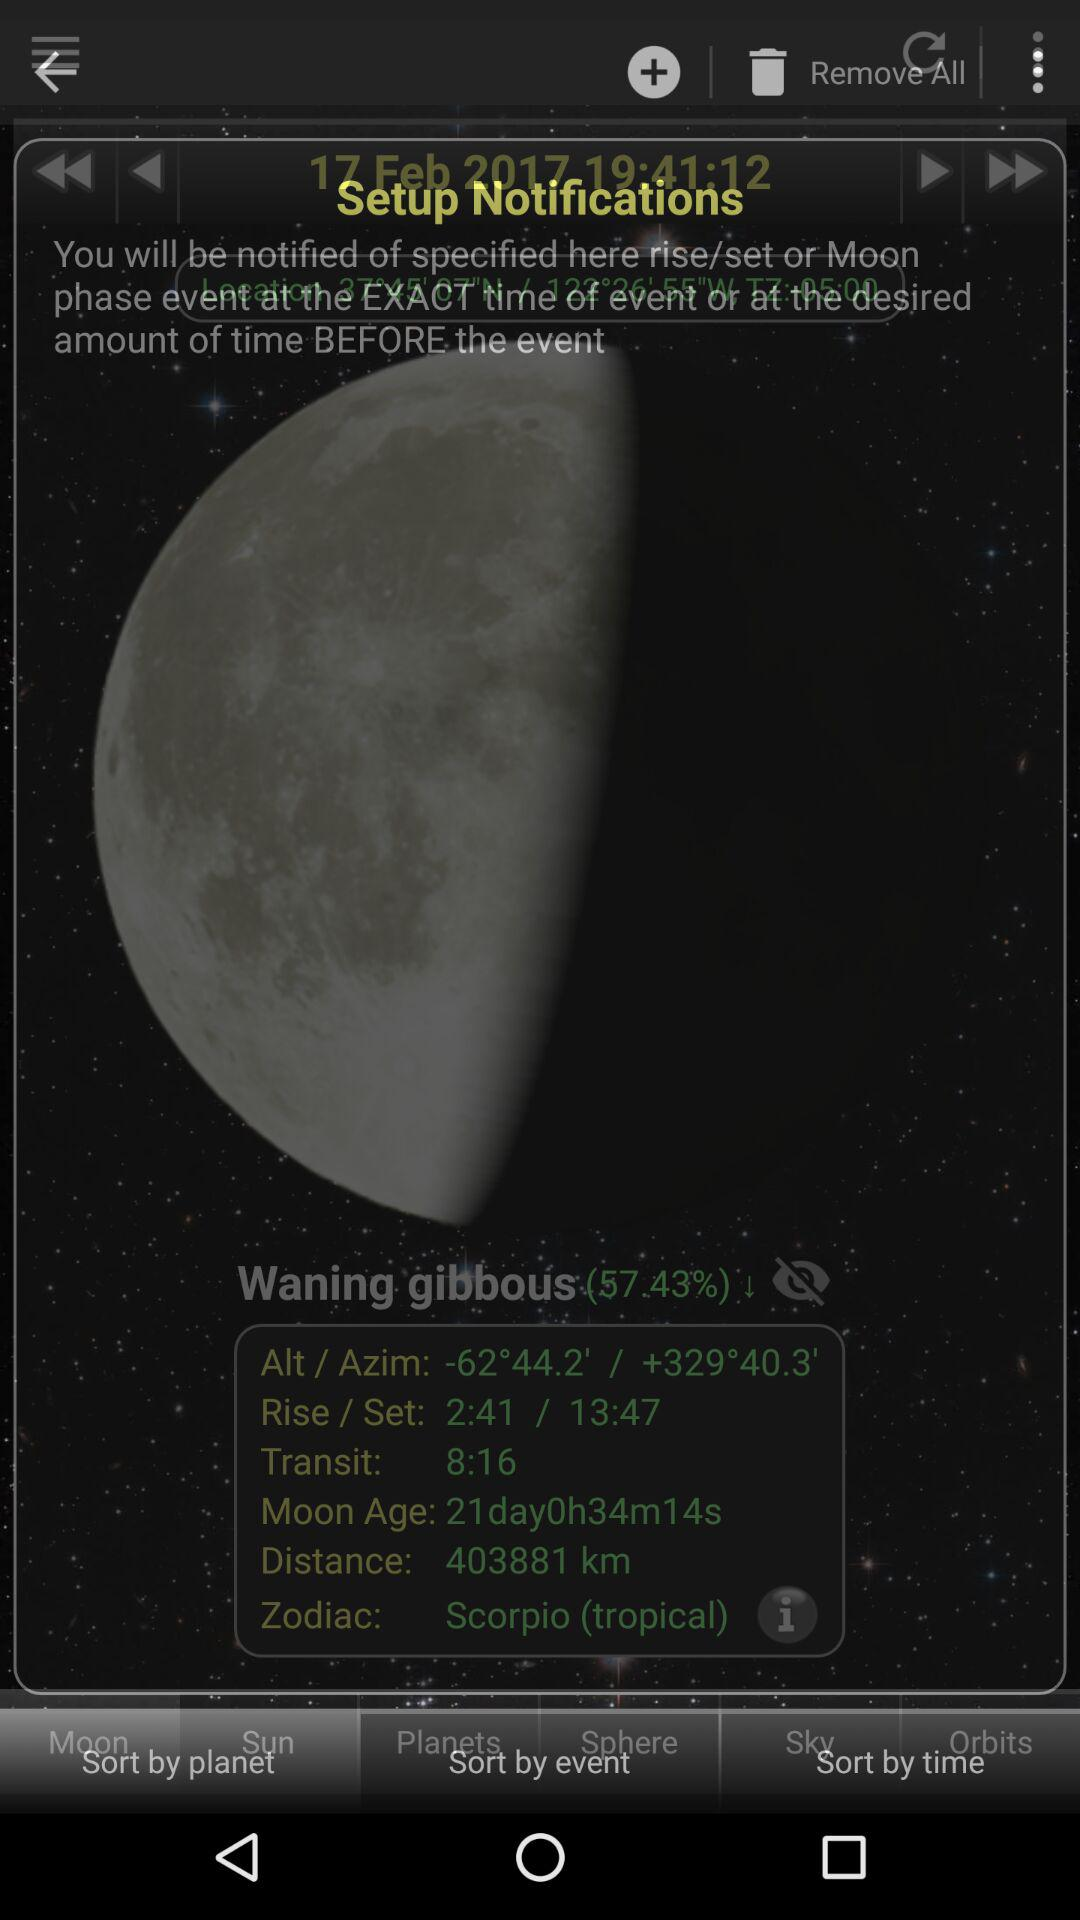What is the distance? The distance is 403881 km. 